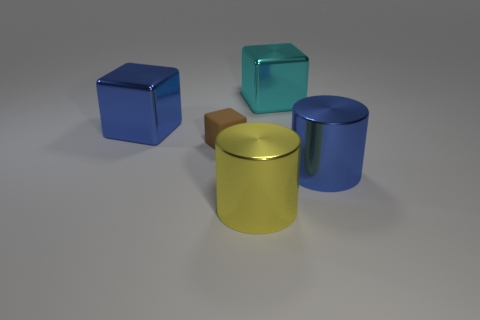How many objects are both in front of the blue cube and on the left side of the large blue metal cylinder?
Your answer should be very brief. 2. How many large yellow metal cylinders are to the right of the big shiny cylinder that is in front of the blue thing that is right of the matte object?
Your answer should be compact. 0. What shape is the large yellow thing?
Your response must be concise. Cylinder. What number of large yellow cylinders have the same material as the cyan thing?
Keep it short and to the point. 1. What is the color of the cylinder that is the same material as the yellow thing?
Your response must be concise. Blue. There is a yellow metal cylinder; does it have the same size as the blue thing on the left side of the tiny block?
Offer a terse response. Yes. What is the material of the large blue object that is on the left side of the big cube behind the shiny thing to the left of the rubber cube?
Give a very brief answer. Metal. What number of things are either tiny brown blocks or large cyan shiny blocks?
Keep it short and to the point. 2. There is a block that is on the right side of the big yellow metal thing; does it have the same color as the shiny block left of the yellow metallic object?
Your response must be concise. No. There is a yellow metallic object that is the same size as the blue cube; what is its shape?
Ensure brevity in your answer.  Cylinder. 